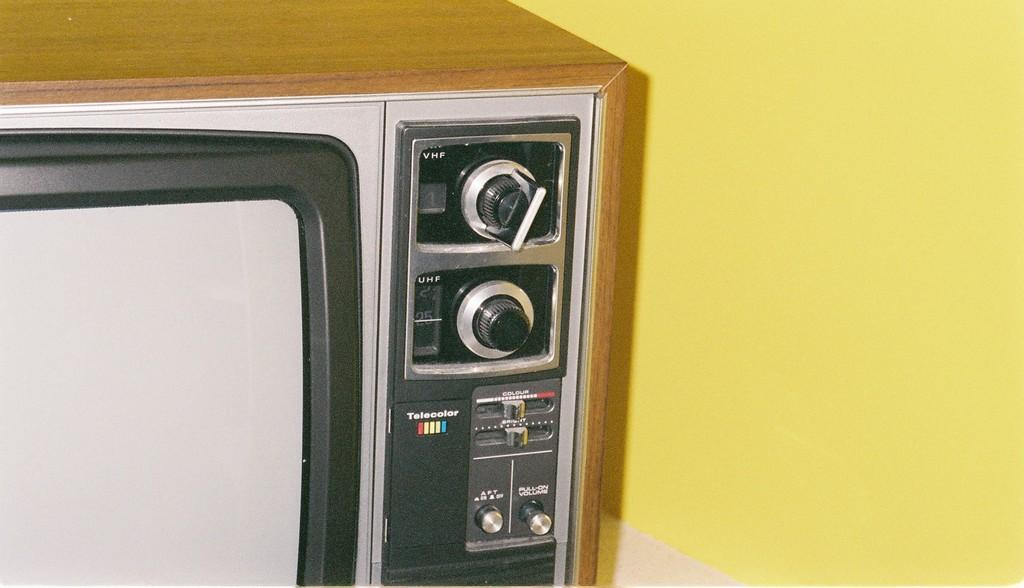<image>
Share a concise interpretation of the image provided. A Telecolor television is old and has knobs to adjust the channels and volume. 